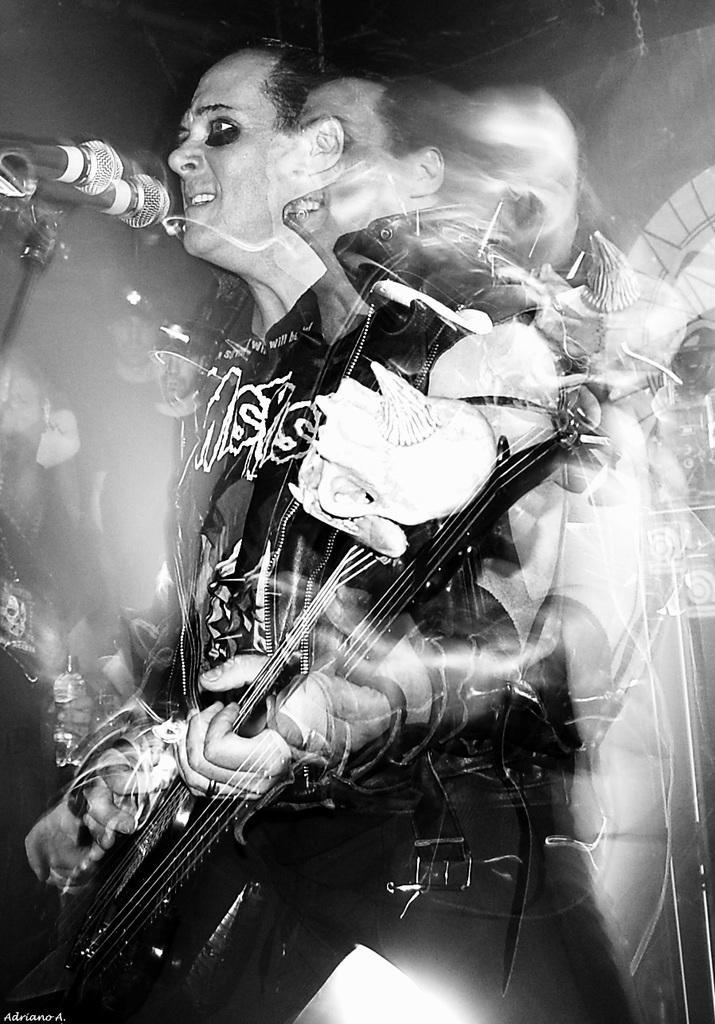In one or two sentences, can you explain what this image depicts? In this picture i can see a human Standing and playing a guitar and singing with the help of a microphone. 